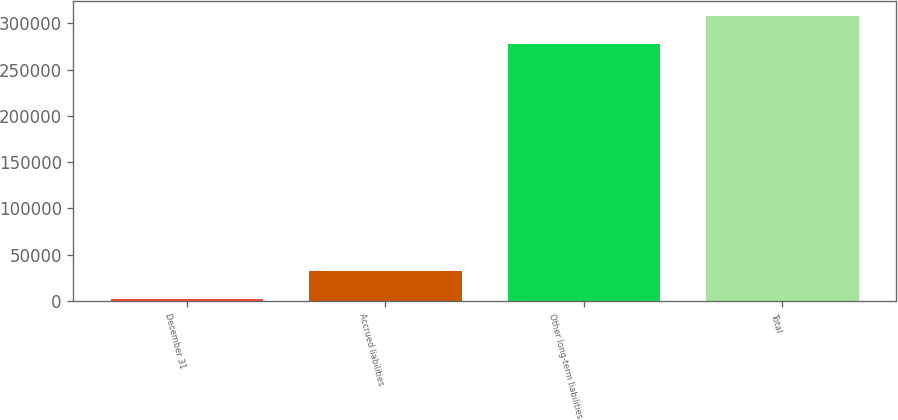Convert chart to OTSL. <chart><loc_0><loc_0><loc_500><loc_500><bar_chart><fcel>December 31<fcel>Accrued liabilities<fcel>Other long-term liabilities<fcel>Total<nl><fcel>2010<fcel>32439<fcel>277963<fcel>308392<nl></chart> 